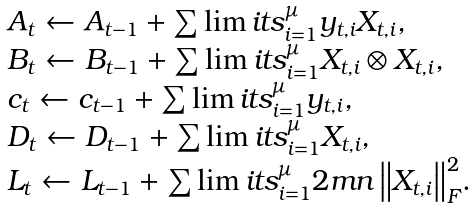<formula> <loc_0><loc_0><loc_500><loc_500>\begin{array} { l } A _ { t } \leftarrow A _ { t - 1 } + \sum \lim i t s _ { i = 1 } ^ { \mu } { y _ { t , i } X _ { t , i } } , \\ B _ { t } \leftarrow B _ { t - 1 } + \sum \lim i t s _ { i = 1 } ^ { \mu } { X _ { t , i } \otimes X _ { t , i } } , \\ c _ { t } \leftarrow c _ { t - 1 } + \sum \lim i t s _ { i = 1 } ^ { \mu } { y _ { t , i } } , \\ D _ { t } \leftarrow D _ { t - 1 } + \sum \lim i t s _ { i = 1 } ^ { \mu } { X _ { t , i } } , \\ L _ { t } \leftarrow L _ { t - 1 } + \sum \lim i t s _ { i = 1 } ^ { \mu } { 2 m n \left \| X _ { t , i } \right \| _ { F } ^ { 2 } } . \end{array}</formula> 